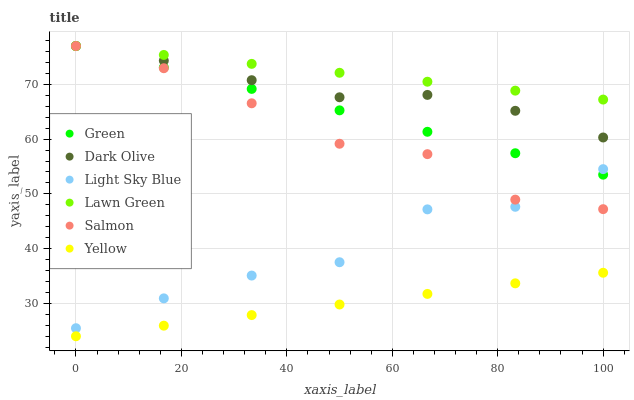Does Yellow have the minimum area under the curve?
Answer yes or no. Yes. Does Lawn Green have the maximum area under the curve?
Answer yes or no. Yes. Does Dark Olive have the minimum area under the curve?
Answer yes or no. No. Does Dark Olive have the maximum area under the curve?
Answer yes or no. No. Is Yellow the smoothest?
Answer yes or no. Yes. Is Light Sky Blue the roughest?
Answer yes or no. Yes. Is Dark Olive the smoothest?
Answer yes or no. No. Is Dark Olive the roughest?
Answer yes or no. No. Does Yellow have the lowest value?
Answer yes or no. Yes. Does Dark Olive have the lowest value?
Answer yes or no. No. Does Green have the highest value?
Answer yes or no. Yes. Does Yellow have the highest value?
Answer yes or no. No. Is Yellow less than Dark Olive?
Answer yes or no. Yes. Is Dark Olive greater than Light Sky Blue?
Answer yes or no. Yes. Does Light Sky Blue intersect Salmon?
Answer yes or no. Yes. Is Light Sky Blue less than Salmon?
Answer yes or no. No. Is Light Sky Blue greater than Salmon?
Answer yes or no. No. Does Yellow intersect Dark Olive?
Answer yes or no. No. 